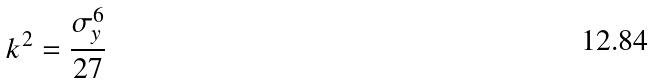<formula> <loc_0><loc_0><loc_500><loc_500>k ^ { 2 } = \frac { \sigma _ { y } ^ { 6 } } { 2 7 }</formula> 